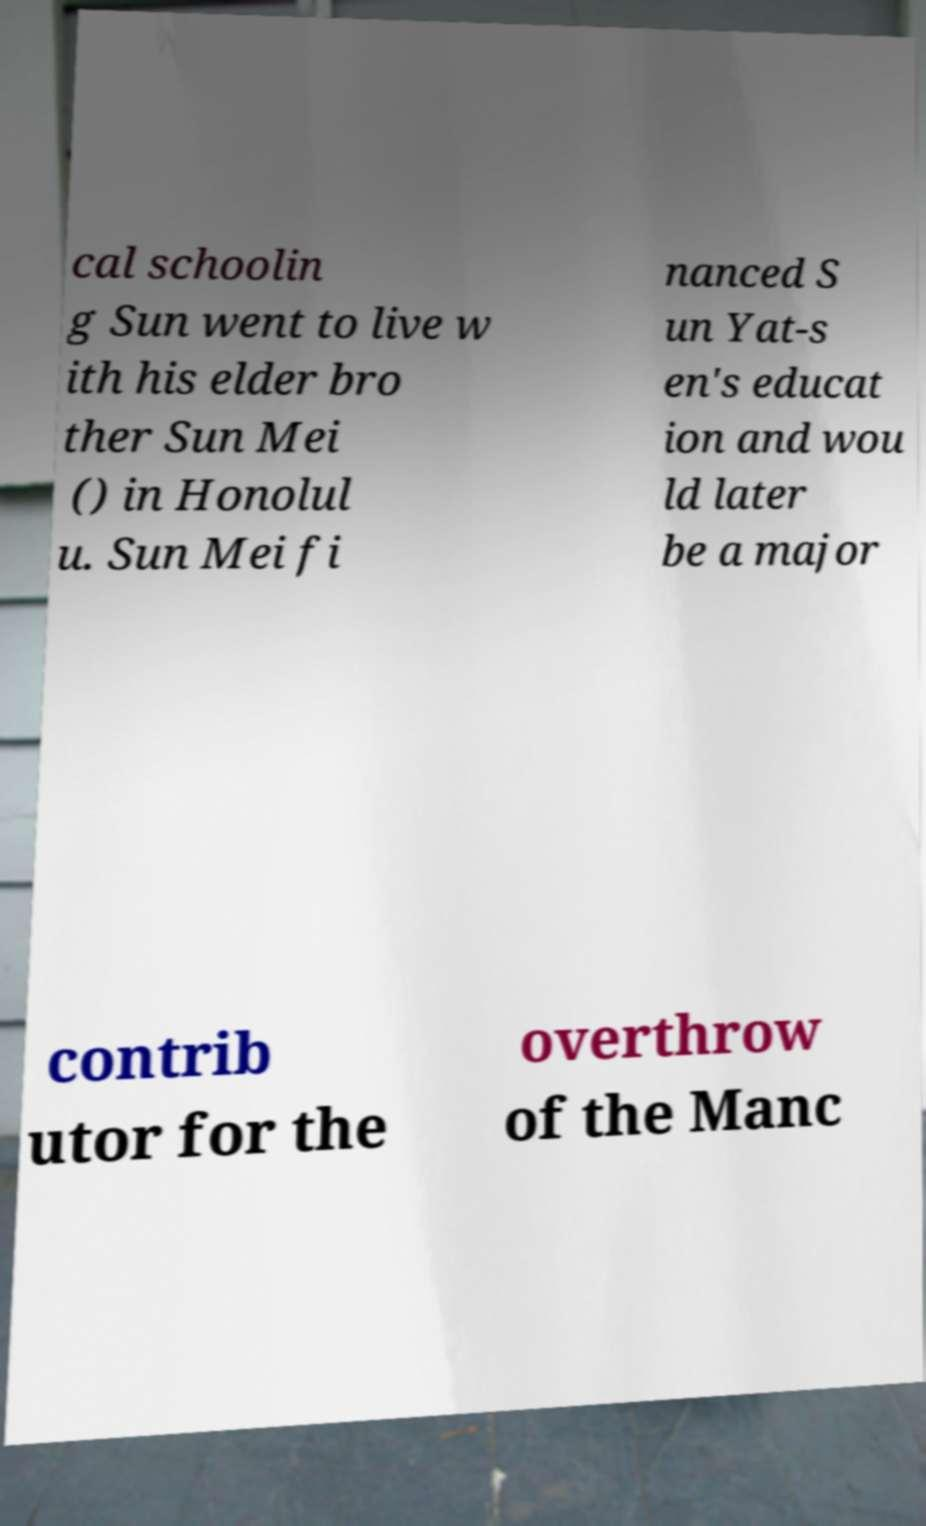Can you accurately transcribe the text from the provided image for me? cal schoolin g Sun went to live w ith his elder bro ther Sun Mei () in Honolul u. Sun Mei fi nanced S un Yat-s en's educat ion and wou ld later be a major contrib utor for the overthrow of the Manc 